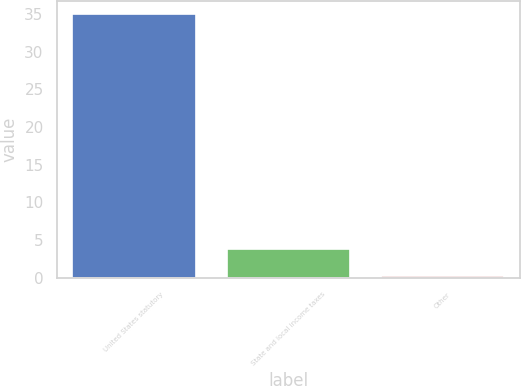Convert chart. <chart><loc_0><loc_0><loc_500><loc_500><bar_chart><fcel>United States statutory<fcel>State and local income taxes<fcel>Other<nl><fcel>35<fcel>3.76<fcel>0.29<nl></chart> 